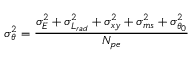Convert formula to latex. <formula><loc_0><loc_0><loc_500><loc_500>\sigma _ { \theta } ^ { 2 } = \frac { \sigma _ { E } ^ { 2 } + \sigma _ { L _ { r a d } } ^ { 2 } + \sigma _ { x y } ^ { 2 } + \sigma _ { m s } ^ { 2 } + \sigma _ { \theta _ { 0 } } ^ { 2 } } { N _ { p e } }</formula> 